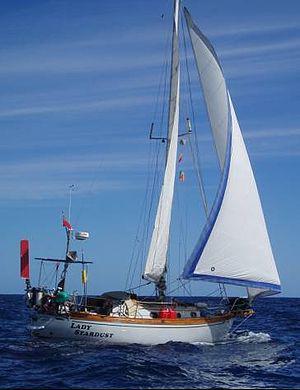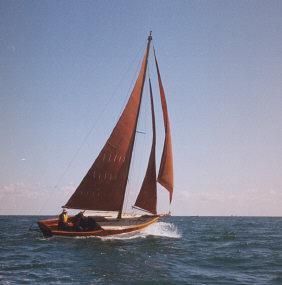The first image is the image on the left, the second image is the image on the right. Considering the images on both sides, is "The sky in the image on the right is cloudless." valid? Answer yes or no. Yes. 